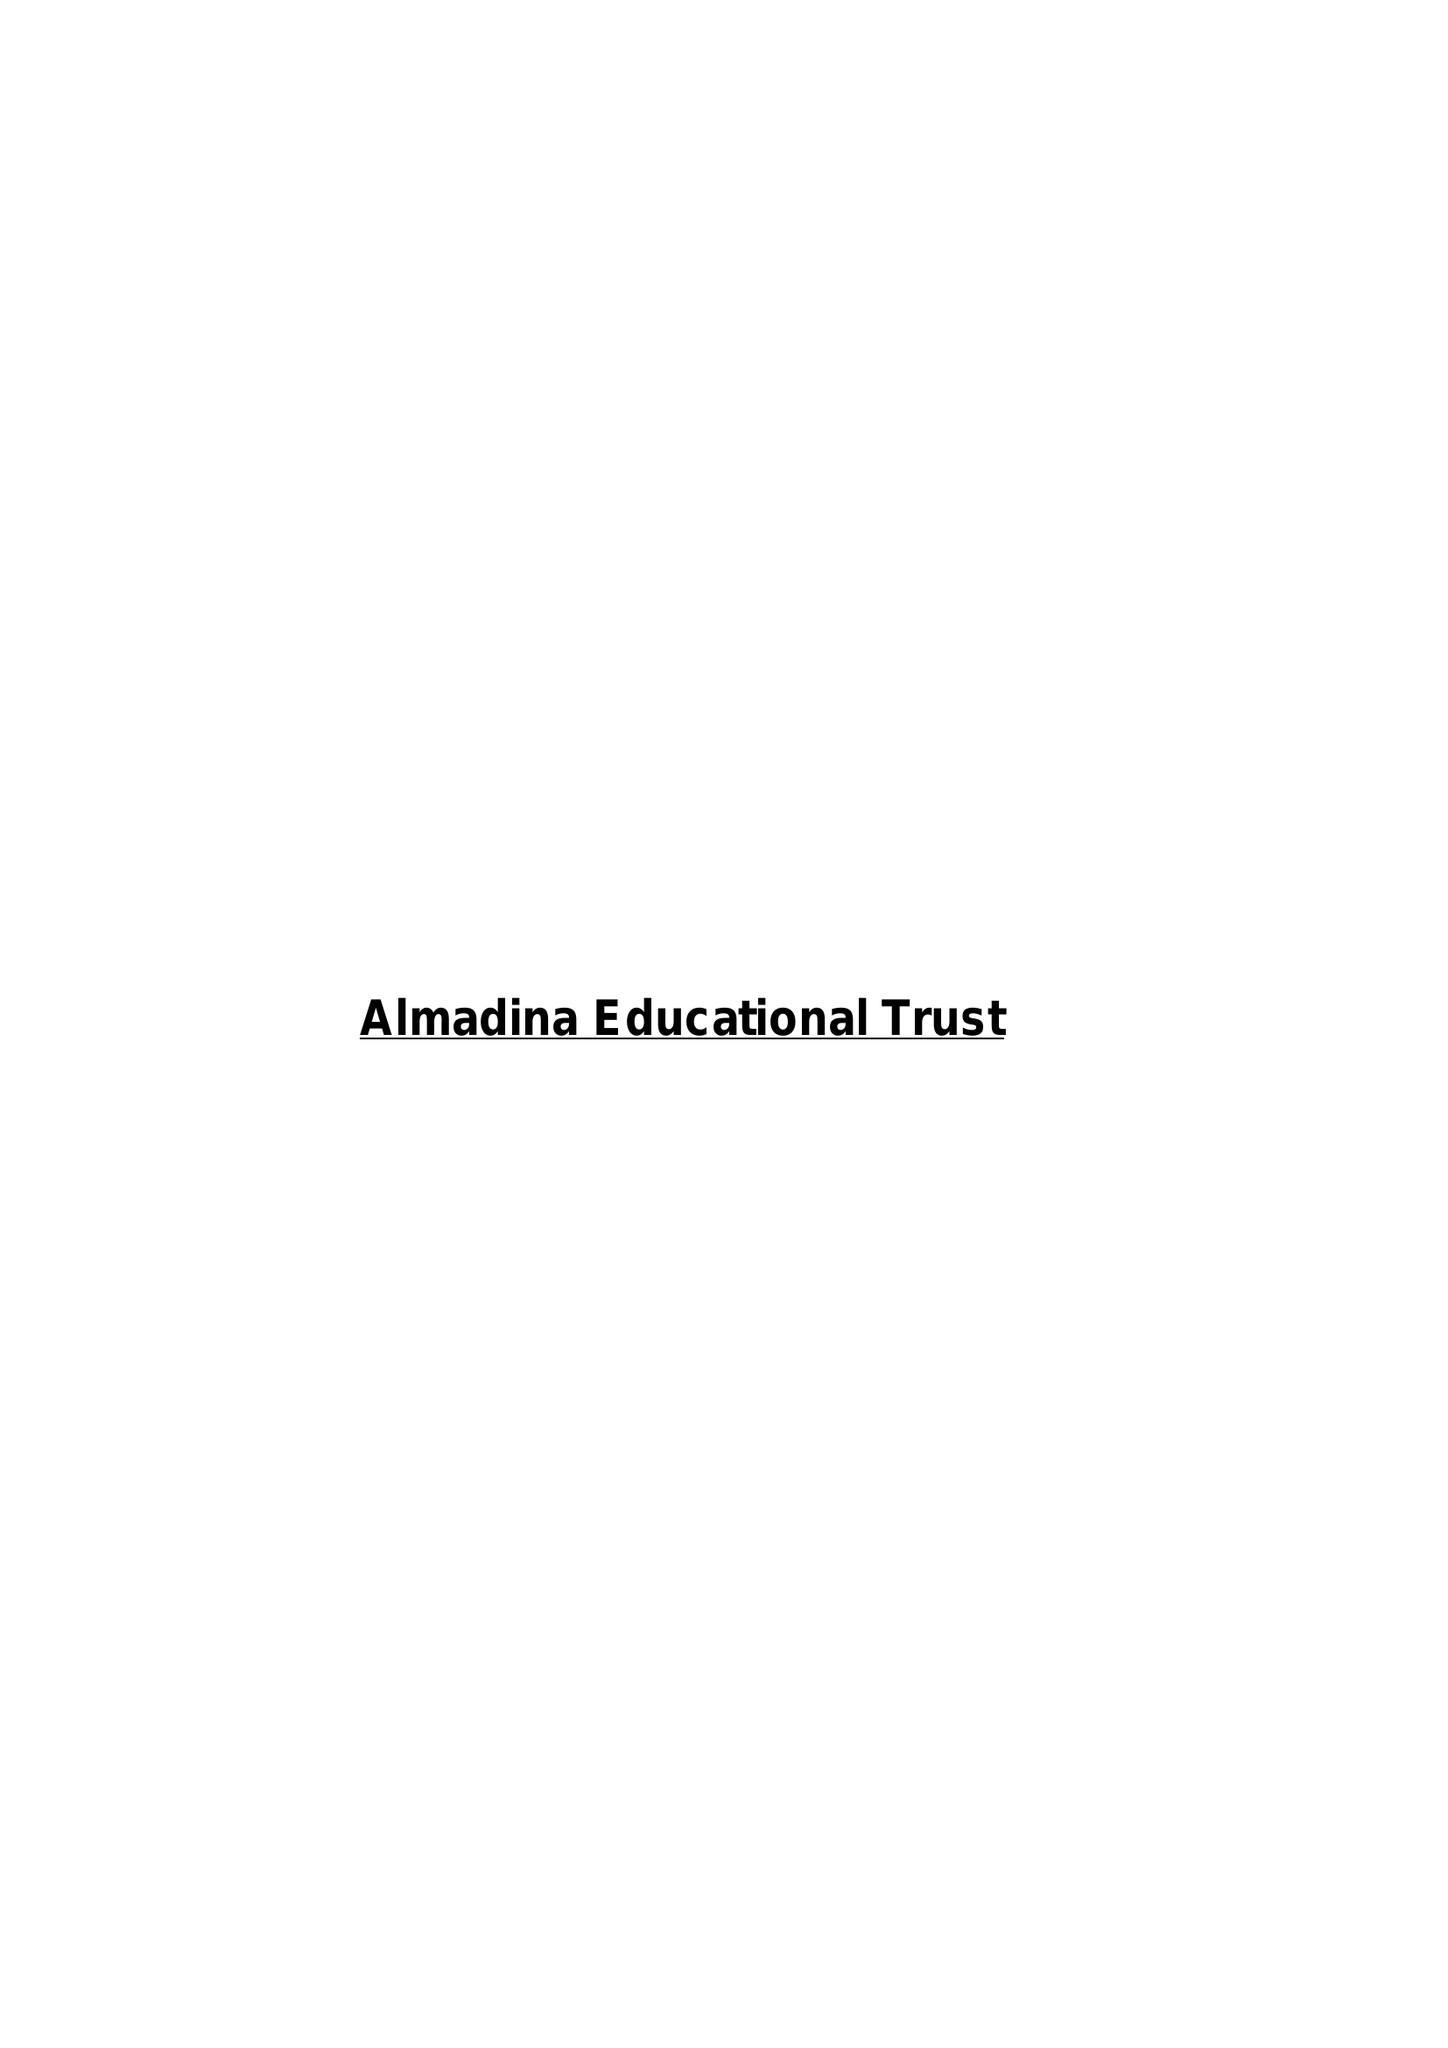What is the value for the address__postcode?
Answer the question using a single word or phrase. OL16 1QZ 